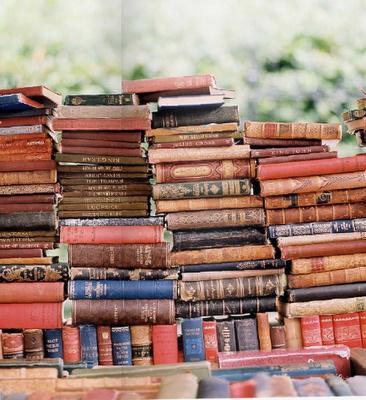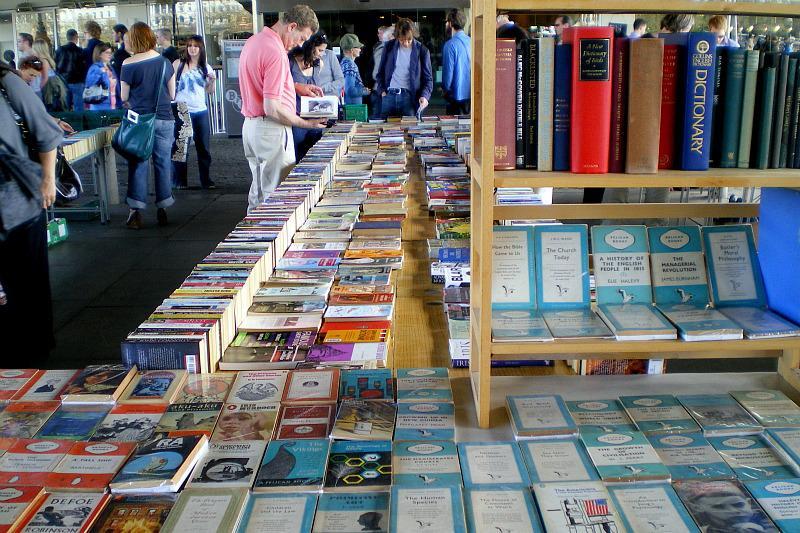The first image is the image on the left, the second image is the image on the right. Examine the images to the left and right. Is the description "There are fewer than ten people in the image on the left." accurate? Answer yes or no. Yes. The first image is the image on the left, the second image is the image on the right. For the images shown, is this caption "The left image is a head-on view of a long display of books under a narrow overhead structure, with the books stacked flat in several center rows, flanked on each side by a row of books stacked vertically, with people browsing on either side." true? Answer yes or no. No. 